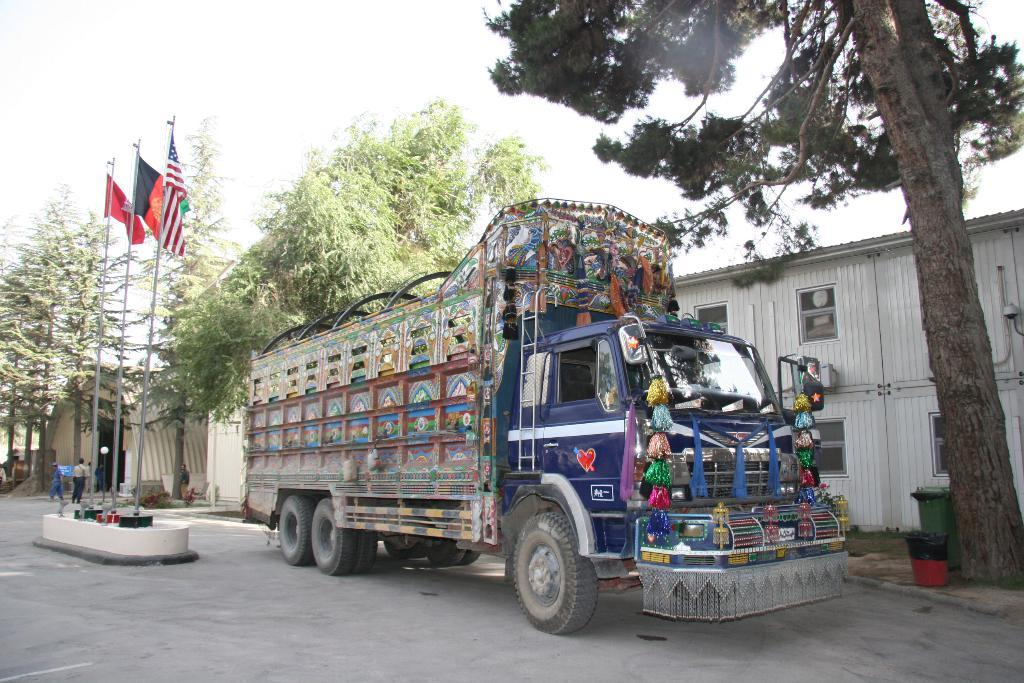What type of vehicle is on the road in the image? There is a blue truck on the road in the image. What is located behind the truck? There is a white warehouse behind the truck. What can be seen behind the warehouse? There are trees visible behind the warehouse. What is in the middle of the road in the image? There are flags in the middle of the road. What is visible at the top of the image? The sky is visible at the top of the image. What type of iron can be seen in the alley behind the warehouse? There is no alley or iron present in the image; it features a blue truck on the road, a white warehouse, trees, flags, and the sky. 